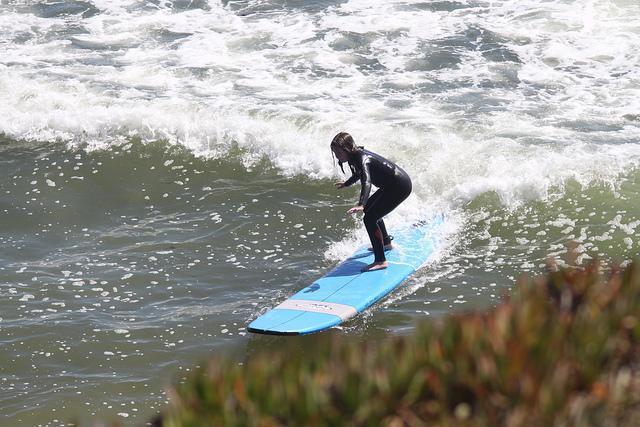How many laptops can be seen?
Give a very brief answer. 0. 